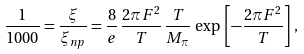<formula> <loc_0><loc_0><loc_500><loc_500>\frac { 1 } { 1 0 0 0 } = \frac { \xi } { \xi _ { n p } } = \frac { 8 } { e } \, \frac { 2 \pi F ^ { 2 } } { T } \, \frac { T } { M _ { \pi } } \, \exp \, \left [ - \frac { 2 \pi F ^ { 2 } } { T } \right ] \, ,</formula> 